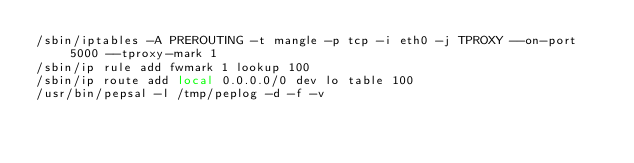<code> <loc_0><loc_0><loc_500><loc_500><_Bash_>/sbin/iptables -A PREROUTING -t mangle -p tcp -i eth0 -j TPROXY --on-port 5000 --tproxy-mark 1
/sbin/ip rule add fwmark 1 lookup 100
/sbin/ip route add local 0.0.0.0/0 dev lo table 100
/usr/bin/pepsal -l /tmp/peplog -d -f -v</code> 